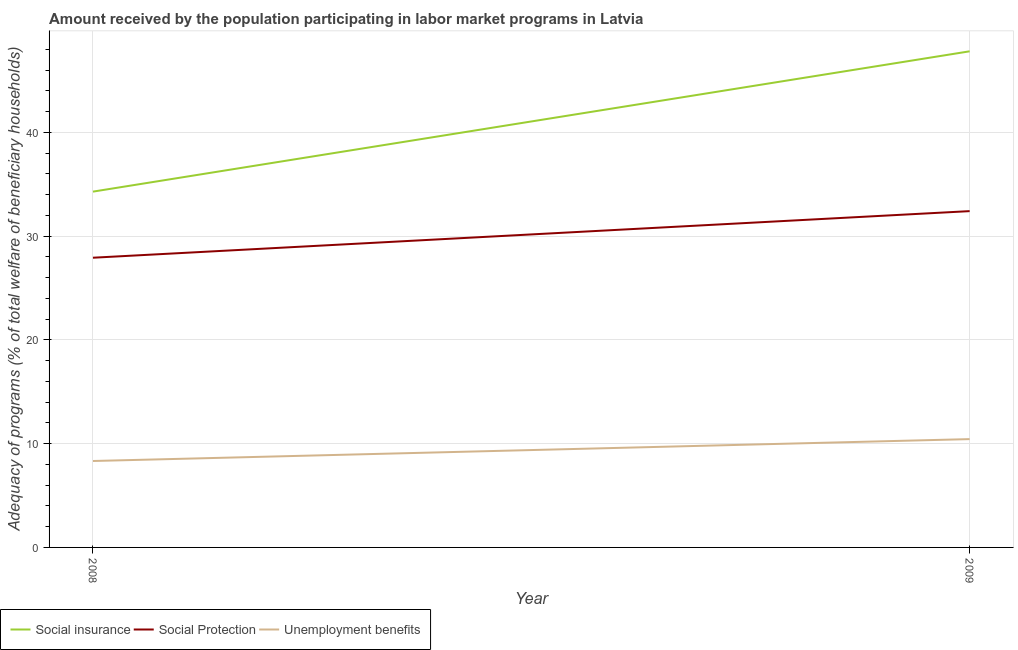What is the amount received by the population participating in social protection programs in 2008?
Keep it short and to the point. 27.93. Across all years, what is the maximum amount received by the population participating in social insurance programs?
Keep it short and to the point. 47.82. Across all years, what is the minimum amount received by the population participating in social insurance programs?
Make the answer very short. 34.3. In which year was the amount received by the population participating in social protection programs maximum?
Make the answer very short. 2009. In which year was the amount received by the population participating in unemployment benefits programs minimum?
Offer a very short reply. 2008. What is the total amount received by the population participating in unemployment benefits programs in the graph?
Your answer should be compact. 18.77. What is the difference between the amount received by the population participating in social insurance programs in 2008 and that in 2009?
Provide a short and direct response. -13.53. What is the difference between the amount received by the population participating in unemployment benefits programs in 2008 and the amount received by the population participating in social insurance programs in 2009?
Keep it short and to the point. -39.49. What is the average amount received by the population participating in social insurance programs per year?
Your answer should be very brief. 41.06. In the year 2008, what is the difference between the amount received by the population participating in social insurance programs and amount received by the population participating in unemployment benefits programs?
Your response must be concise. 25.97. What is the ratio of the amount received by the population participating in unemployment benefits programs in 2008 to that in 2009?
Give a very brief answer. 0.8. Is the amount received by the population participating in social insurance programs in 2008 less than that in 2009?
Keep it short and to the point. Yes. Is it the case that in every year, the sum of the amount received by the population participating in social insurance programs and amount received by the population participating in social protection programs is greater than the amount received by the population participating in unemployment benefits programs?
Make the answer very short. Yes. Does the amount received by the population participating in social protection programs monotonically increase over the years?
Make the answer very short. Yes. Is the amount received by the population participating in unemployment benefits programs strictly less than the amount received by the population participating in social insurance programs over the years?
Your answer should be compact. Yes. How many lines are there?
Give a very brief answer. 3. Are the values on the major ticks of Y-axis written in scientific E-notation?
Offer a very short reply. No. Does the graph contain grids?
Ensure brevity in your answer.  Yes. What is the title of the graph?
Provide a succinct answer. Amount received by the population participating in labor market programs in Latvia. Does "Argument" appear as one of the legend labels in the graph?
Provide a succinct answer. No. What is the label or title of the Y-axis?
Offer a terse response. Adequacy of programs (% of total welfare of beneficiary households). What is the Adequacy of programs (% of total welfare of beneficiary households) of Social insurance in 2008?
Ensure brevity in your answer.  34.3. What is the Adequacy of programs (% of total welfare of beneficiary households) in Social Protection in 2008?
Offer a terse response. 27.93. What is the Adequacy of programs (% of total welfare of beneficiary households) in Unemployment benefits in 2008?
Offer a very short reply. 8.33. What is the Adequacy of programs (% of total welfare of beneficiary households) of Social insurance in 2009?
Your answer should be compact. 47.82. What is the Adequacy of programs (% of total welfare of beneficiary households) of Social Protection in 2009?
Your answer should be very brief. 32.42. What is the Adequacy of programs (% of total welfare of beneficiary households) in Unemployment benefits in 2009?
Provide a succinct answer. 10.44. Across all years, what is the maximum Adequacy of programs (% of total welfare of beneficiary households) in Social insurance?
Your response must be concise. 47.82. Across all years, what is the maximum Adequacy of programs (% of total welfare of beneficiary households) in Social Protection?
Keep it short and to the point. 32.42. Across all years, what is the maximum Adequacy of programs (% of total welfare of beneficiary households) of Unemployment benefits?
Your response must be concise. 10.44. Across all years, what is the minimum Adequacy of programs (% of total welfare of beneficiary households) of Social insurance?
Your response must be concise. 34.3. Across all years, what is the minimum Adequacy of programs (% of total welfare of beneficiary households) of Social Protection?
Your answer should be compact. 27.93. Across all years, what is the minimum Adequacy of programs (% of total welfare of beneficiary households) of Unemployment benefits?
Ensure brevity in your answer.  8.33. What is the total Adequacy of programs (% of total welfare of beneficiary households) in Social insurance in the graph?
Your answer should be compact. 82.12. What is the total Adequacy of programs (% of total welfare of beneficiary households) of Social Protection in the graph?
Your response must be concise. 60.34. What is the total Adequacy of programs (% of total welfare of beneficiary households) of Unemployment benefits in the graph?
Offer a very short reply. 18.77. What is the difference between the Adequacy of programs (% of total welfare of beneficiary households) of Social insurance in 2008 and that in 2009?
Give a very brief answer. -13.53. What is the difference between the Adequacy of programs (% of total welfare of beneficiary households) in Social Protection in 2008 and that in 2009?
Offer a very short reply. -4.49. What is the difference between the Adequacy of programs (% of total welfare of beneficiary households) of Unemployment benefits in 2008 and that in 2009?
Keep it short and to the point. -2.11. What is the difference between the Adequacy of programs (% of total welfare of beneficiary households) in Social insurance in 2008 and the Adequacy of programs (% of total welfare of beneficiary households) in Social Protection in 2009?
Offer a terse response. 1.88. What is the difference between the Adequacy of programs (% of total welfare of beneficiary households) in Social insurance in 2008 and the Adequacy of programs (% of total welfare of beneficiary households) in Unemployment benefits in 2009?
Provide a succinct answer. 23.86. What is the difference between the Adequacy of programs (% of total welfare of beneficiary households) of Social Protection in 2008 and the Adequacy of programs (% of total welfare of beneficiary households) of Unemployment benefits in 2009?
Provide a succinct answer. 17.48. What is the average Adequacy of programs (% of total welfare of beneficiary households) of Social insurance per year?
Make the answer very short. 41.06. What is the average Adequacy of programs (% of total welfare of beneficiary households) of Social Protection per year?
Provide a succinct answer. 30.17. What is the average Adequacy of programs (% of total welfare of beneficiary households) in Unemployment benefits per year?
Your answer should be compact. 9.39. In the year 2008, what is the difference between the Adequacy of programs (% of total welfare of beneficiary households) of Social insurance and Adequacy of programs (% of total welfare of beneficiary households) of Social Protection?
Provide a succinct answer. 6.37. In the year 2008, what is the difference between the Adequacy of programs (% of total welfare of beneficiary households) in Social insurance and Adequacy of programs (% of total welfare of beneficiary households) in Unemployment benefits?
Your answer should be compact. 25.97. In the year 2008, what is the difference between the Adequacy of programs (% of total welfare of beneficiary households) in Social Protection and Adequacy of programs (% of total welfare of beneficiary households) in Unemployment benefits?
Offer a very short reply. 19.59. In the year 2009, what is the difference between the Adequacy of programs (% of total welfare of beneficiary households) of Social insurance and Adequacy of programs (% of total welfare of beneficiary households) of Social Protection?
Ensure brevity in your answer.  15.41. In the year 2009, what is the difference between the Adequacy of programs (% of total welfare of beneficiary households) of Social insurance and Adequacy of programs (% of total welfare of beneficiary households) of Unemployment benefits?
Provide a succinct answer. 37.38. In the year 2009, what is the difference between the Adequacy of programs (% of total welfare of beneficiary households) of Social Protection and Adequacy of programs (% of total welfare of beneficiary households) of Unemployment benefits?
Give a very brief answer. 21.98. What is the ratio of the Adequacy of programs (% of total welfare of beneficiary households) of Social insurance in 2008 to that in 2009?
Provide a succinct answer. 0.72. What is the ratio of the Adequacy of programs (% of total welfare of beneficiary households) of Social Protection in 2008 to that in 2009?
Your response must be concise. 0.86. What is the ratio of the Adequacy of programs (% of total welfare of beneficiary households) of Unemployment benefits in 2008 to that in 2009?
Your answer should be very brief. 0.8. What is the difference between the highest and the second highest Adequacy of programs (% of total welfare of beneficiary households) in Social insurance?
Make the answer very short. 13.53. What is the difference between the highest and the second highest Adequacy of programs (% of total welfare of beneficiary households) in Social Protection?
Ensure brevity in your answer.  4.49. What is the difference between the highest and the second highest Adequacy of programs (% of total welfare of beneficiary households) in Unemployment benefits?
Provide a short and direct response. 2.11. What is the difference between the highest and the lowest Adequacy of programs (% of total welfare of beneficiary households) of Social insurance?
Your response must be concise. 13.53. What is the difference between the highest and the lowest Adequacy of programs (% of total welfare of beneficiary households) in Social Protection?
Make the answer very short. 4.49. What is the difference between the highest and the lowest Adequacy of programs (% of total welfare of beneficiary households) of Unemployment benefits?
Your answer should be compact. 2.11. 